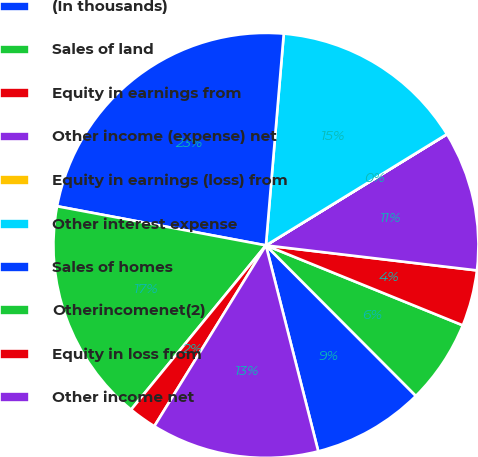Convert chart. <chart><loc_0><loc_0><loc_500><loc_500><pie_chart><fcel>(In thousands)<fcel>Sales of land<fcel>Equity in earnings from<fcel>Other income (expense) net<fcel>Equity in earnings (loss) from<fcel>Other interest expense<fcel>Sales of homes<fcel>Otherincomenet(2)<fcel>Equity in loss from<fcel>Other income net<nl><fcel>8.51%<fcel>6.39%<fcel>4.26%<fcel>10.64%<fcel>0.01%<fcel>14.89%<fcel>23.39%<fcel>17.01%<fcel>2.14%<fcel>12.76%<nl></chart> 